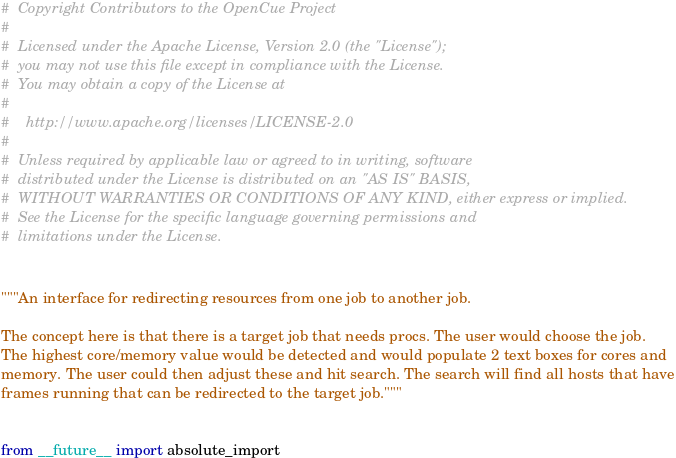<code> <loc_0><loc_0><loc_500><loc_500><_Python_>#  Copyright Contributors to the OpenCue Project
#
#  Licensed under the Apache License, Version 2.0 (the "License");
#  you may not use this file except in compliance with the License.
#  You may obtain a copy of the License at
#
#    http://www.apache.org/licenses/LICENSE-2.0
#
#  Unless required by applicable law or agreed to in writing, software
#  distributed under the License is distributed on an "AS IS" BASIS,
#  WITHOUT WARRANTIES OR CONDITIONS OF ANY KIND, either express or implied.
#  See the License for the specific language governing permissions and
#  limitations under the License.


"""An interface for redirecting resources from one job to another job.

The concept here is that there is a target job that needs procs. The user would choose the job.
The highest core/memory value would be detected and would populate 2 text boxes for cores and
memory. The user could then adjust these and hit search. The search will find all hosts that have
frames running that can be redirected to the target job."""


from __future__ import absolute_import</code> 